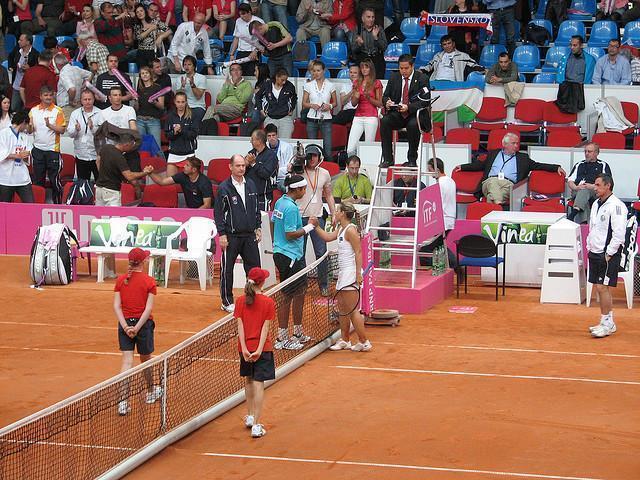At which point in the match are these players?
Select the accurate answer and provide explanation: 'Answer: answer
Rationale: rationale.'
Options: Mid way, beginning, half time, end. Answer: end.
Rationale: After a tennis match is over, the players traditionally shake hands. 